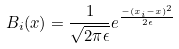Convert formula to latex. <formula><loc_0><loc_0><loc_500><loc_500>B _ { i } ( x ) = \frac { 1 } { \sqrt { 2 \pi \epsilon } } e ^ { \frac { - ( x _ { i } - x ) ^ { 2 } } { 2 \epsilon } }</formula> 